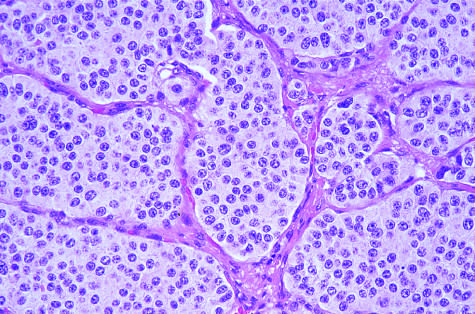does the histologic appearance demonstrate small round, uniform nuclei and moderate cytoplasm?
Answer the question using a single word or phrase. Yes 